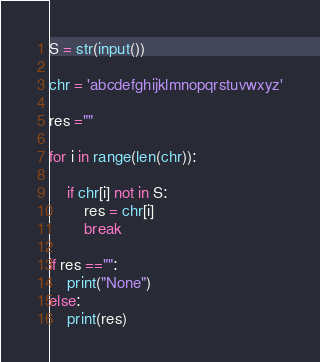<code> <loc_0><loc_0><loc_500><loc_500><_Python_>S = str(input())

chr = 'abcdefghijklmnopqrstuvwxyz'

res =""

for i in range(len(chr)):
    
    if chr[i] not in S:
        res = chr[i]
        break
    
if res =="":
    print("None")
else:
    print(res)</code> 